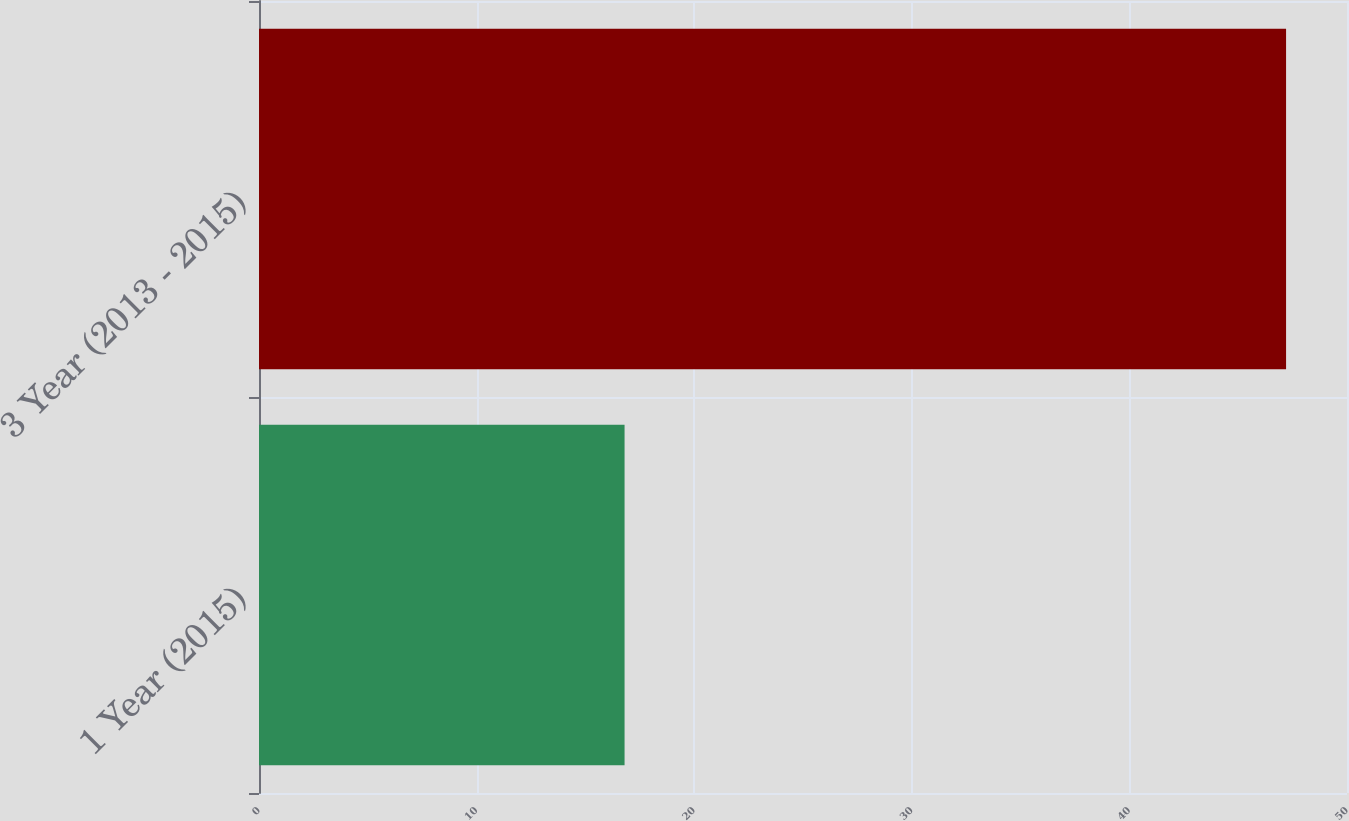Convert chart to OTSL. <chart><loc_0><loc_0><loc_500><loc_500><bar_chart><fcel>1 Year (2015)<fcel>3 Year (2013 - 2015)<nl><fcel>16.8<fcel>47.2<nl></chart> 